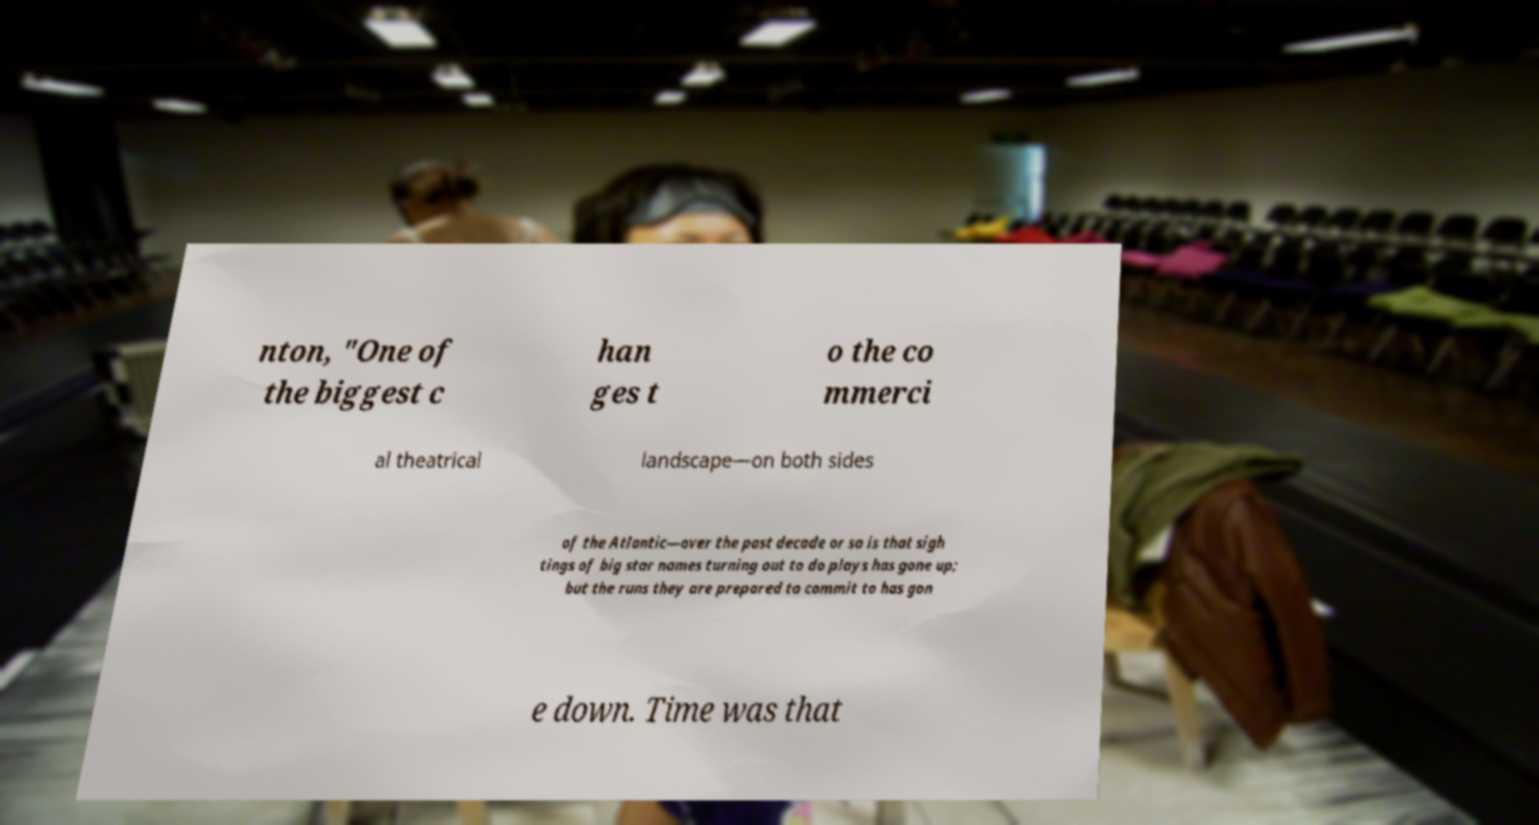Could you assist in decoding the text presented in this image and type it out clearly? nton, "One of the biggest c han ges t o the co mmerci al theatrical landscape—on both sides of the Atlantic—over the past decade or so is that sigh tings of big star names turning out to do plays has gone up; but the runs they are prepared to commit to has gon e down. Time was that 